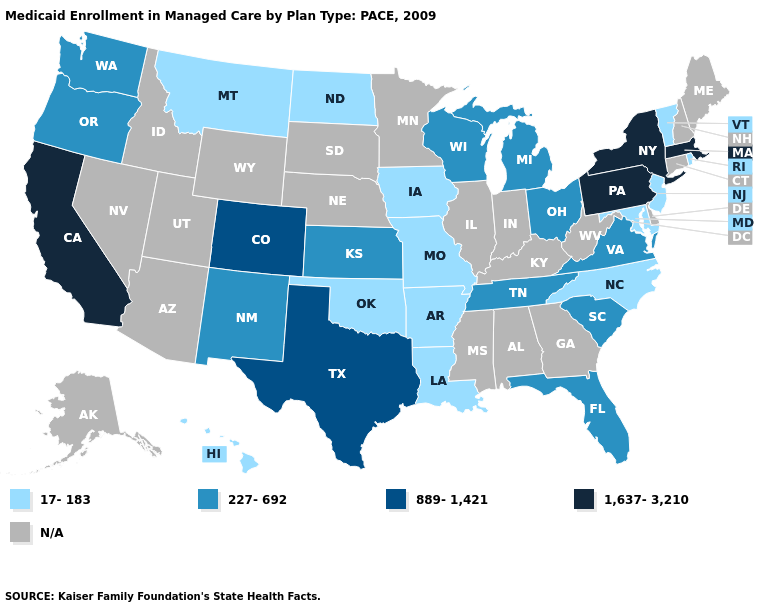How many symbols are there in the legend?
Concise answer only. 5. Among the states that border Oregon , does Washington have the highest value?
Give a very brief answer. No. What is the lowest value in states that border Iowa?
Concise answer only. 17-183. Among the states that border Ohio , does Michigan have the lowest value?
Write a very short answer. Yes. Does New Mexico have the highest value in the West?
Quick response, please. No. What is the highest value in the Northeast ?
Quick response, please. 1,637-3,210. Among the states that border Wyoming , does Colorado have the highest value?
Quick response, please. Yes. Which states hav the highest value in the MidWest?
Answer briefly. Kansas, Michigan, Ohio, Wisconsin. What is the value of Pennsylvania?
Give a very brief answer. 1,637-3,210. What is the value of Georgia?
Give a very brief answer. N/A. What is the highest value in the USA?
Be succinct. 1,637-3,210. What is the value of Texas?
Write a very short answer. 889-1,421. What is the value of Georgia?
Quick response, please. N/A. 